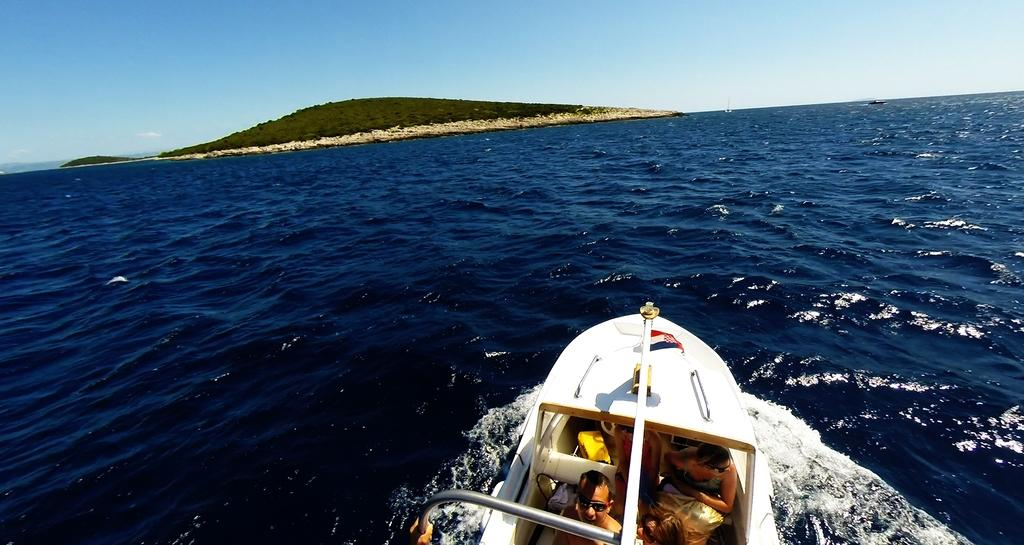What are the people in the image doing? The people in the image are riding on a boat. Where is the boat located? The boat is on the water. What can be seen in the background of the image? There are trees, a mountain, and the sky visible in the background of the image. How many cats are sitting on the truck in the image? There are no cats or trucks present in the image. 